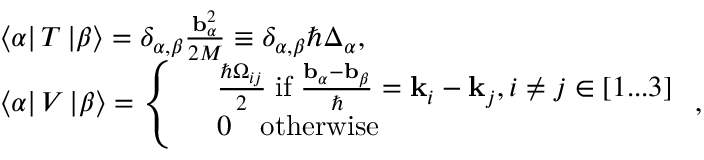<formula> <loc_0><loc_0><loc_500><loc_500>\begin{array} { r l } & { \left \langle \alpha \right | T \left | \beta \right \rangle = \delta _ { \alpha , \beta } \frac { b _ { \alpha } ^ { 2 } } { 2 M } \equiv \delta _ { \alpha , \beta } \hbar { \Delta } _ { \alpha } , } \\ & { \left \langle \alpha \right | V \left | \beta \right \rangle = \left \{ \begin{array} { r l } & { \frac { \hbar { \Omega } _ { i j } } { 2 } \, i f \, \frac { b _ { \alpha } - b _ { \beta } } { } = k _ { i } - k _ { j } , i \neq j \in [ 1 \dots 3 ] } \\ & { 0 \quad o t h e r w i s e } \end{array} , } \end{array}</formula> 